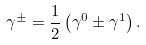Convert formula to latex. <formula><loc_0><loc_0><loc_500><loc_500>\gamma ^ { \pm } = \frac { 1 } { 2 } \left ( \gamma ^ { 0 } \pm \gamma ^ { 1 } \right ) .</formula> 